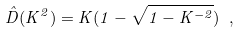<formula> <loc_0><loc_0><loc_500><loc_500>\hat { D } ( K ^ { 2 } ) = K ( 1 - \sqrt { 1 - K ^ { - 2 } } ) \ ,</formula> 